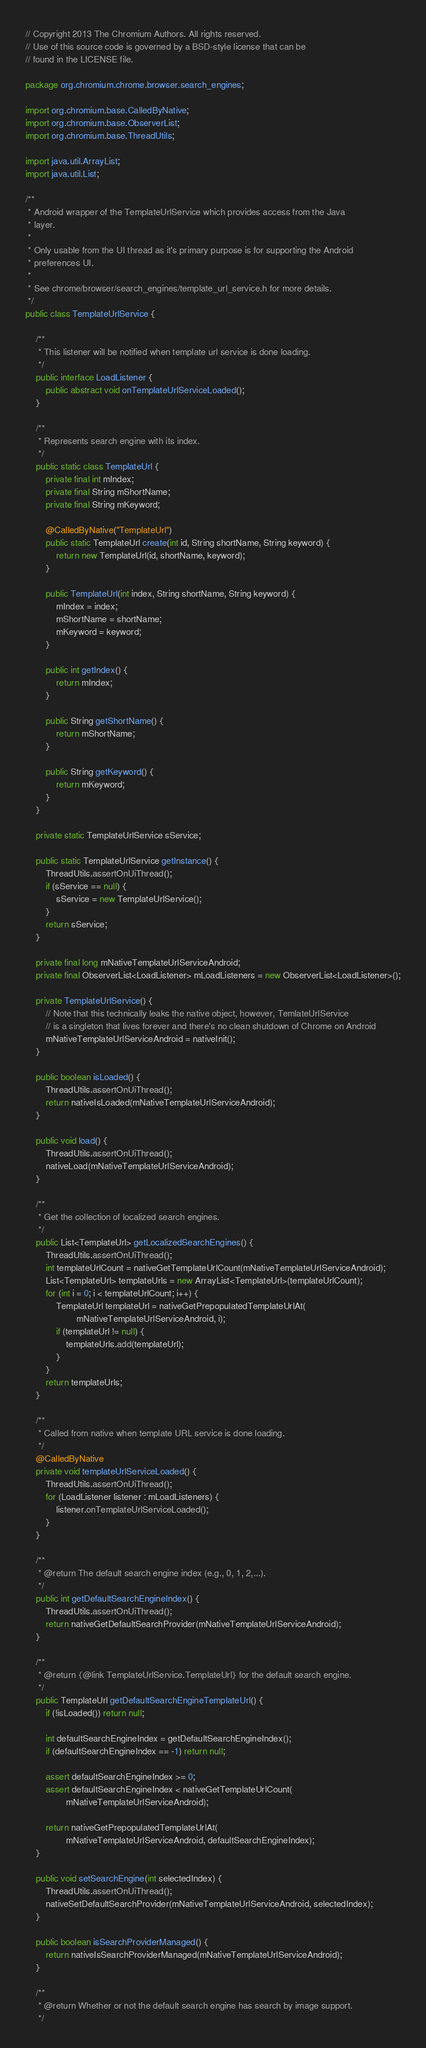<code> <loc_0><loc_0><loc_500><loc_500><_Java_>// Copyright 2013 The Chromium Authors. All rights reserved.
// Use of this source code is governed by a BSD-style license that can be
// found in the LICENSE file.

package org.chromium.chrome.browser.search_engines;

import org.chromium.base.CalledByNative;
import org.chromium.base.ObserverList;
import org.chromium.base.ThreadUtils;

import java.util.ArrayList;
import java.util.List;

/**
 * Android wrapper of the TemplateUrlService which provides access from the Java
 * layer.
 *
 * Only usable from the UI thread as it's primary purpose is for supporting the Android
 * preferences UI.
 *
 * See chrome/browser/search_engines/template_url_service.h for more details.
 */
public class TemplateUrlService {

    /**
     * This listener will be notified when template url service is done loading.
     */
    public interface LoadListener {
        public abstract void onTemplateUrlServiceLoaded();
    }

    /**
     * Represents search engine with its index.
     */
    public static class TemplateUrl {
        private final int mIndex;
        private final String mShortName;
        private final String mKeyword;

        @CalledByNative("TemplateUrl")
        public static TemplateUrl create(int id, String shortName, String keyword) {
            return new TemplateUrl(id, shortName, keyword);
        }

        public TemplateUrl(int index, String shortName, String keyword) {
            mIndex = index;
            mShortName = shortName;
            mKeyword = keyword;
        }

        public int getIndex() {
            return mIndex;
        }

        public String getShortName() {
            return mShortName;
        }

        public String getKeyword() {
            return mKeyword;
        }
    }

    private static TemplateUrlService sService;

    public static TemplateUrlService getInstance() {
        ThreadUtils.assertOnUiThread();
        if (sService == null) {
            sService = new TemplateUrlService();
        }
        return sService;
    }

    private final long mNativeTemplateUrlServiceAndroid;
    private final ObserverList<LoadListener> mLoadListeners = new ObserverList<LoadListener>();

    private TemplateUrlService() {
        // Note that this technically leaks the native object, however, TemlateUrlService
        // is a singleton that lives forever and there's no clean shutdown of Chrome on Android
        mNativeTemplateUrlServiceAndroid = nativeInit();
    }

    public boolean isLoaded() {
        ThreadUtils.assertOnUiThread();
        return nativeIsLoaded(mNativeTemplateUrlServiceAndroid);
    }

    public void load() {
        ThreadUtils.assertOnUiThread();
        nativeLoad(mNativeTemplateUrlServiceAndroid);
    }

    /**
     * Get the collection of localized search engines.
     */
    public List<TemplateUrl> getLocalizedSearchEngines() {
        ThreadUtils.assertOnUiThread();
        int templateUrlCount = nativeGetTemplateUrlCount(mNativeTemplateUrlServiceAndroid);
        List<TemplateUrl> templateUrls = new ArrayList<TemplateUrl>(templateUrlCount);
        for (int i = 0; i < templateUrlCount; i++) {
            TemplateUrl templateUrl = nativeGetPrepopulatedTemplateUrlAt(
                    mNativeTemplateUrlServiceAndroid, i);
            if (templateUrl != null) {
                templateUrls.add(templateUrl);
            }
        }
        return templateUrls;
    }

    /**
     * Called from native when template URL service is done loading.
     */
    @CalledByNative
    private void templateUrlServiceLoaded() {
        ThreadUtils.assertOnUiThread();
        for (LoadListener listener : mLoadListeners) {
            listener.onTemplateUrlServiceLoaded();
        }
    }

    /**
     * @return The default search engine index (e.g., 0, 1, 2,...).
     */
    public int getDefaultSearchEngineIndex() {
        ThreadUtils.assertOnUiThread();
        return nativeGetDefaultSearchProvider(mNativeTemplateUrlServiceAndroid);
    }

    /**
     * @return {@link TemplateUrlService.TemplateUrl} for the default search engine.
     */
    public TemplateUrl getDefaultSearchEngineTemplateUrl() {
        if (!isLoaded()) return null;

        int defaultSearchEngineIndex = getDefaultSearchEngineIndex();
        if (defaultSearchEngineIndex == -1) return null;

        assert defaultSearchEngineIndex >= 0;
        assert defaultSearchEngineIndex < nativeGetTemplateUrlCount(
                mNativeTemplateUrlServiceAndroid);

        return nativeGetPrepopulatedTemplateUrlAt(
                mNativeTemplateUrlServiceAndroid, defaultSearchEngineIndex);
    }

    public void setSearchEngine(int selectedIndex) {
        ThreadUtils.assertOnUiThread();
        nativeSetDefaultSearchProvider(mNativeTemplateUrlServiceAndroid, selectedIndex);
    }

    public boolean isSearchProviderManaged() {
        return nativeIsSearchProviderManaged(mNativeTemplateUrlServiceAndroid);
    }

    /**
     * @return Whether or not the default search engine has search by image support.
     */</code> 